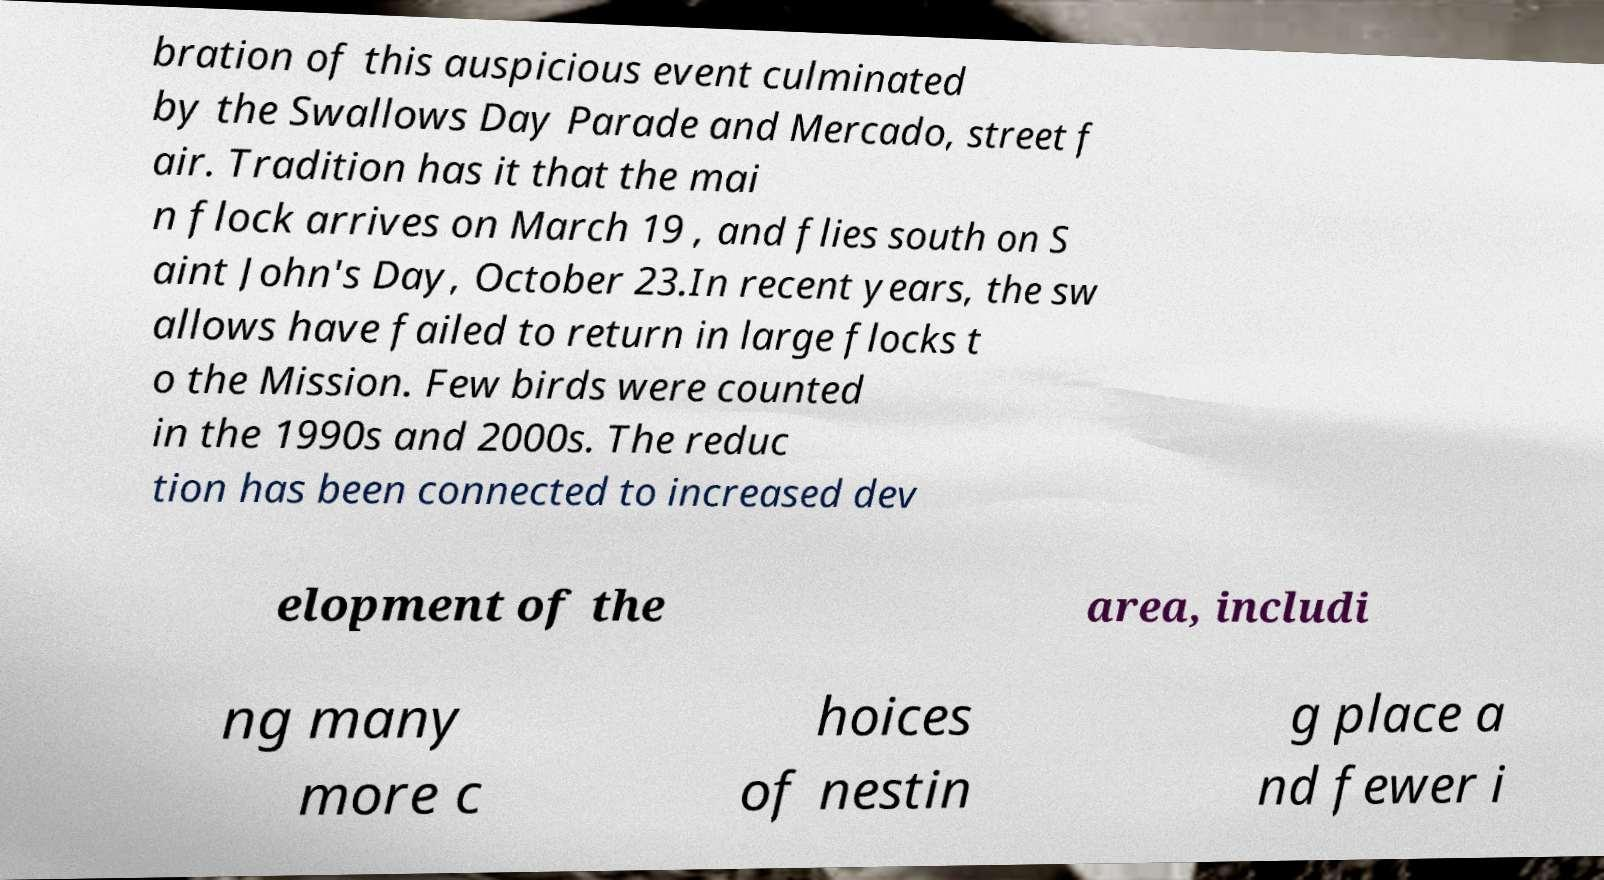For documentation purposes, I need the text within this image transcribed. Could you provide that? bration of this auspicious event culminated by the Swallows Day Parade and Mercado, street f air. Tradition has it that the mai n flock arrives on March 19 , and flies south on S aint John's Day, October 23.In recent years, the sw allows have failed to return in large flocks t o the Mission. Few birds were counted in the 1990s and 2000s. The reduc tion has been connected to increased dev elopment of the area, includi ng many more c hoices of nestin g place a nd fewer i 